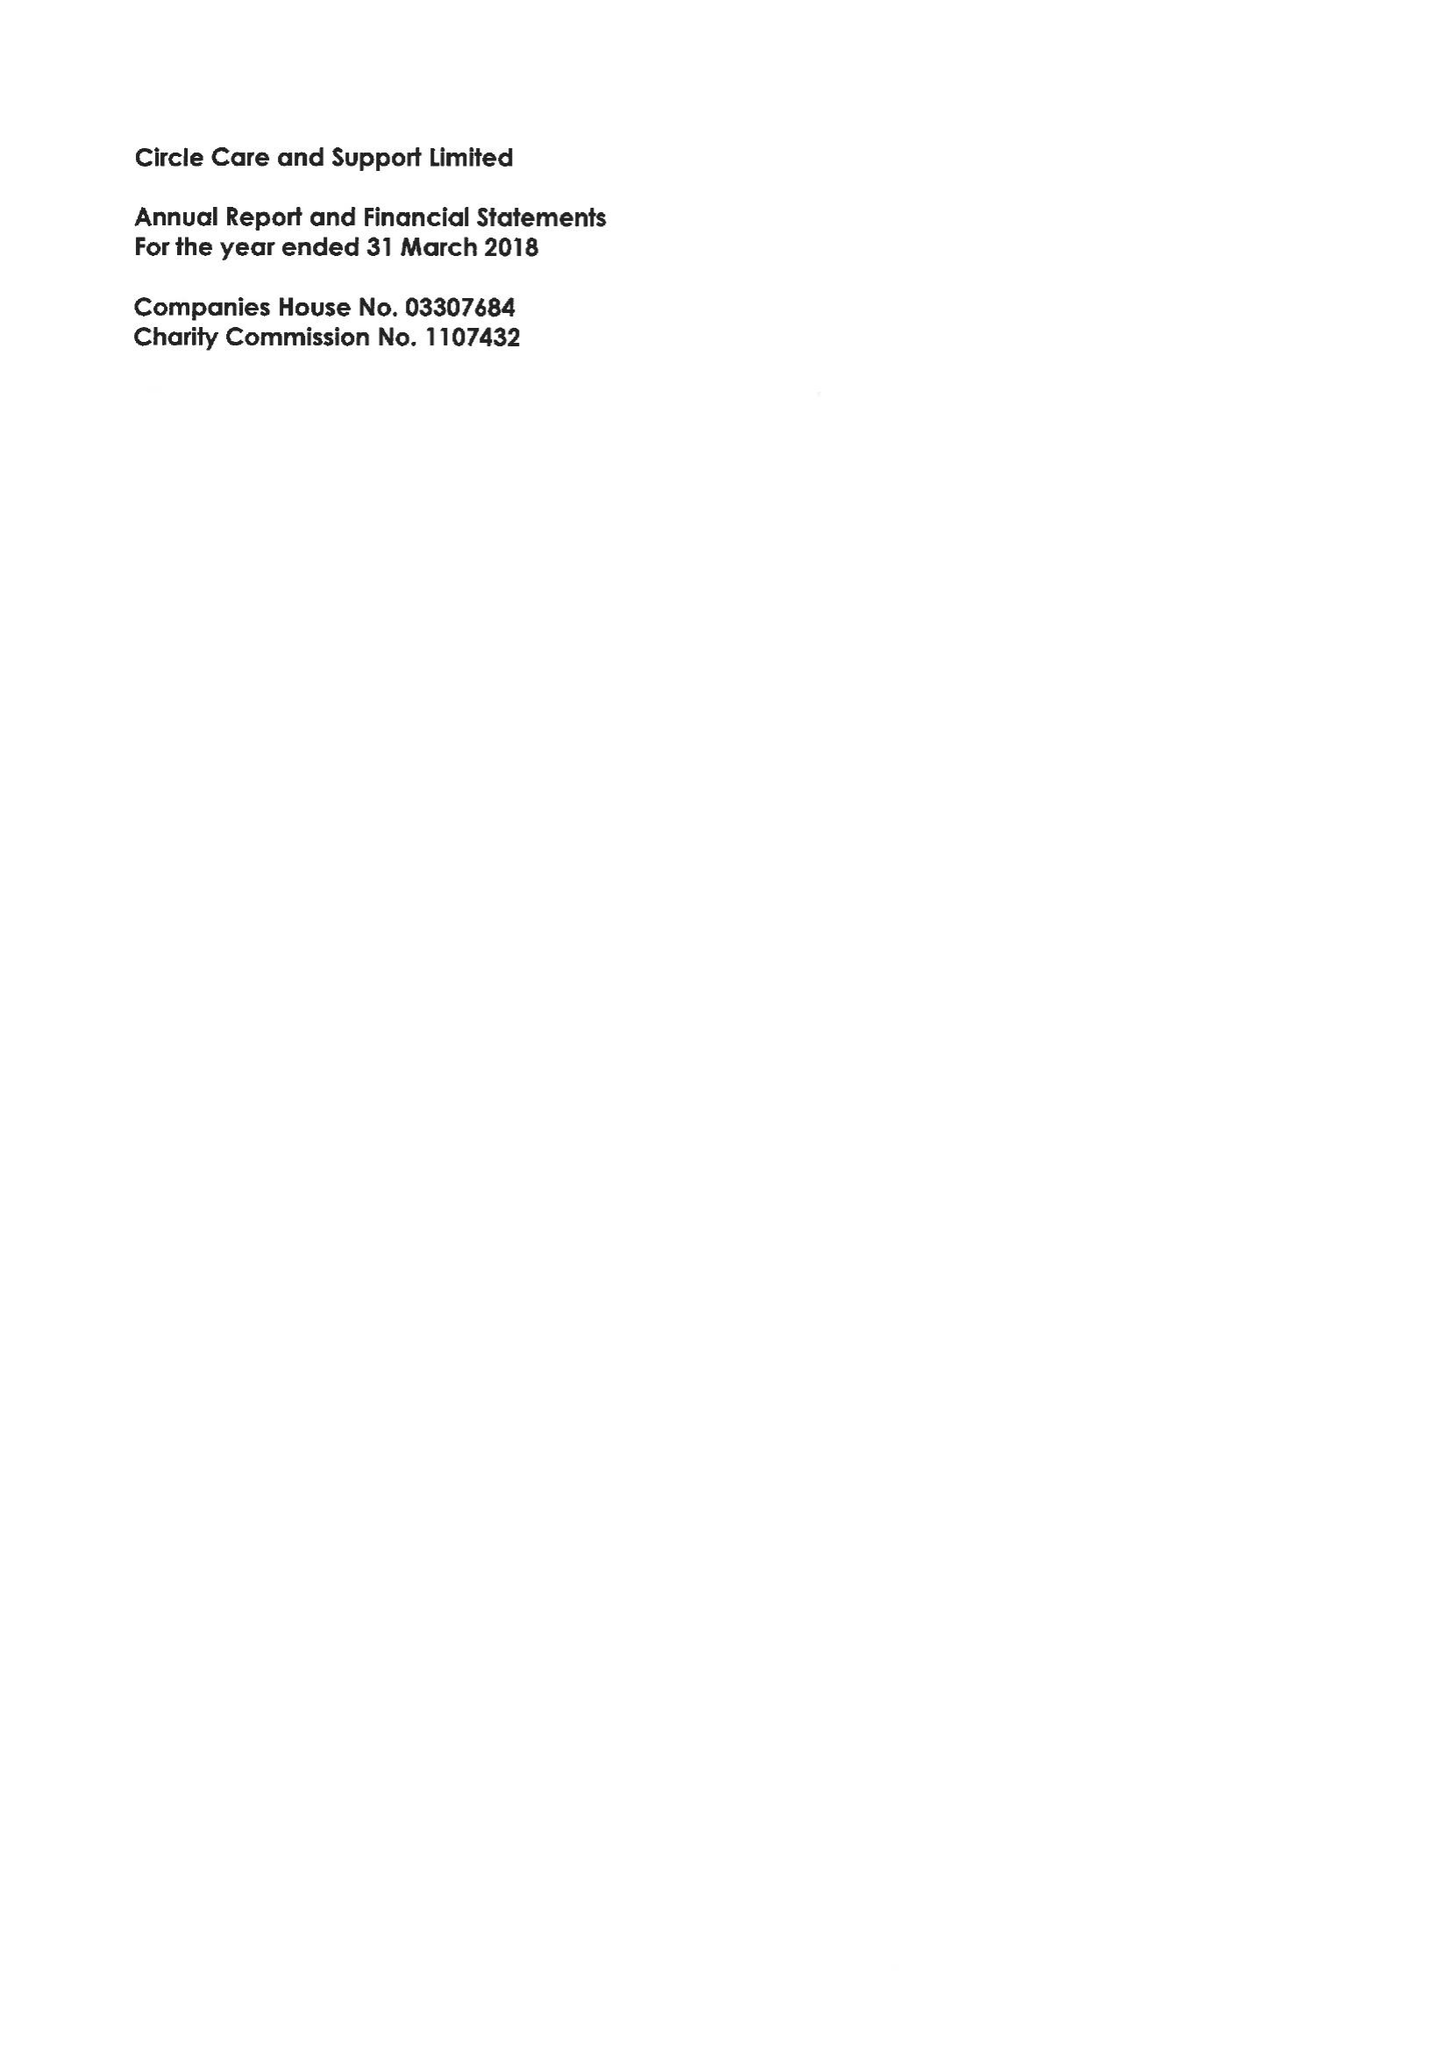What is the value for the charity_name?
Answer the question using a single word or phrase. Circle Care and Suppor Ltd. 